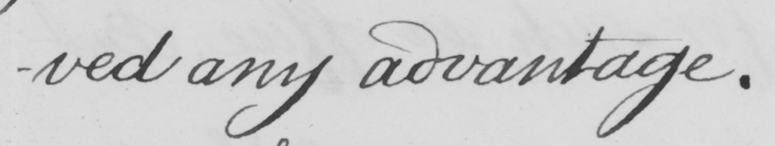Can you tell me what this handwritten text says? -ved any advantage . 